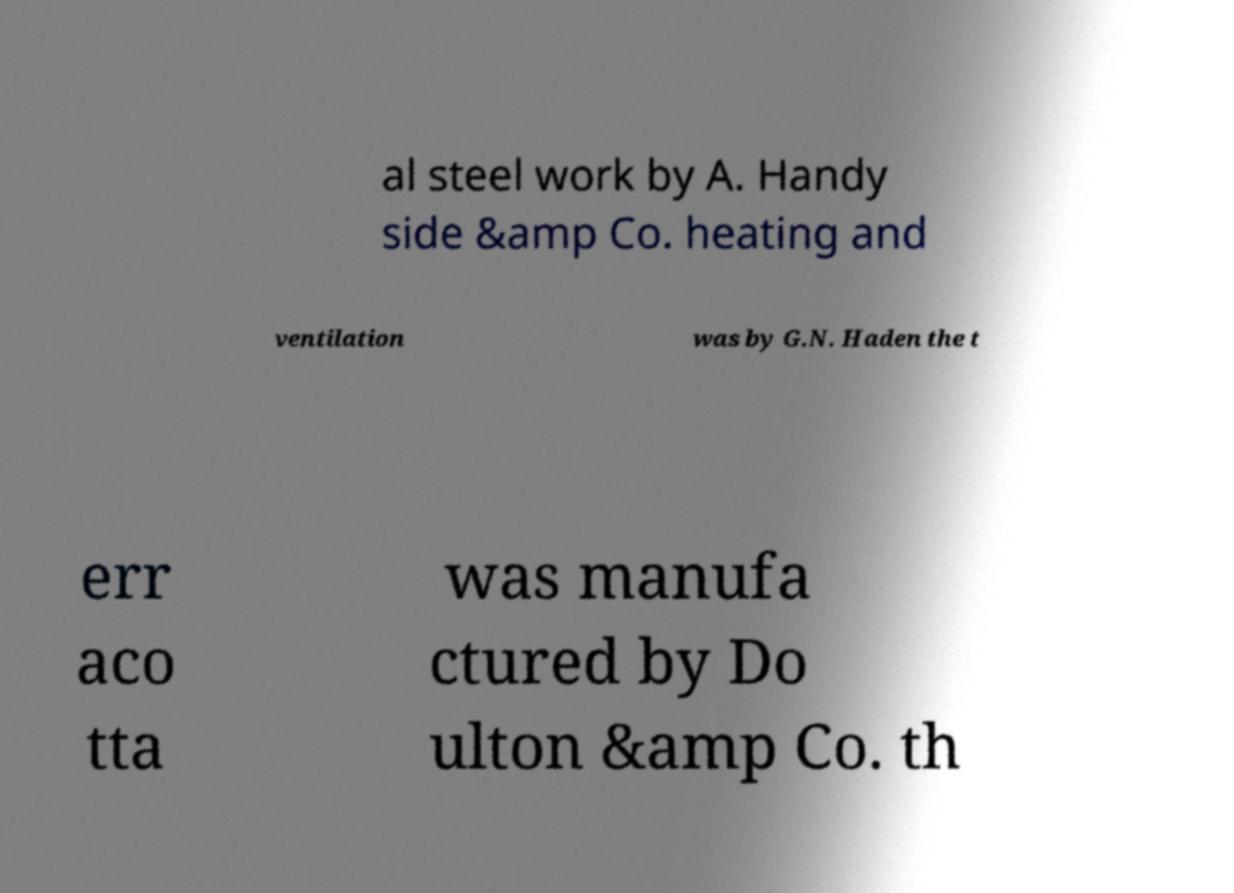There's text embedded in this image that I need extracted. Can you transcribe it verbatim? al steel work by A. Handy side &amp Co. heating and ventilation was by G.N. Haden the t err aco tta was manufa ctured by Do ulton &amp Co. th 